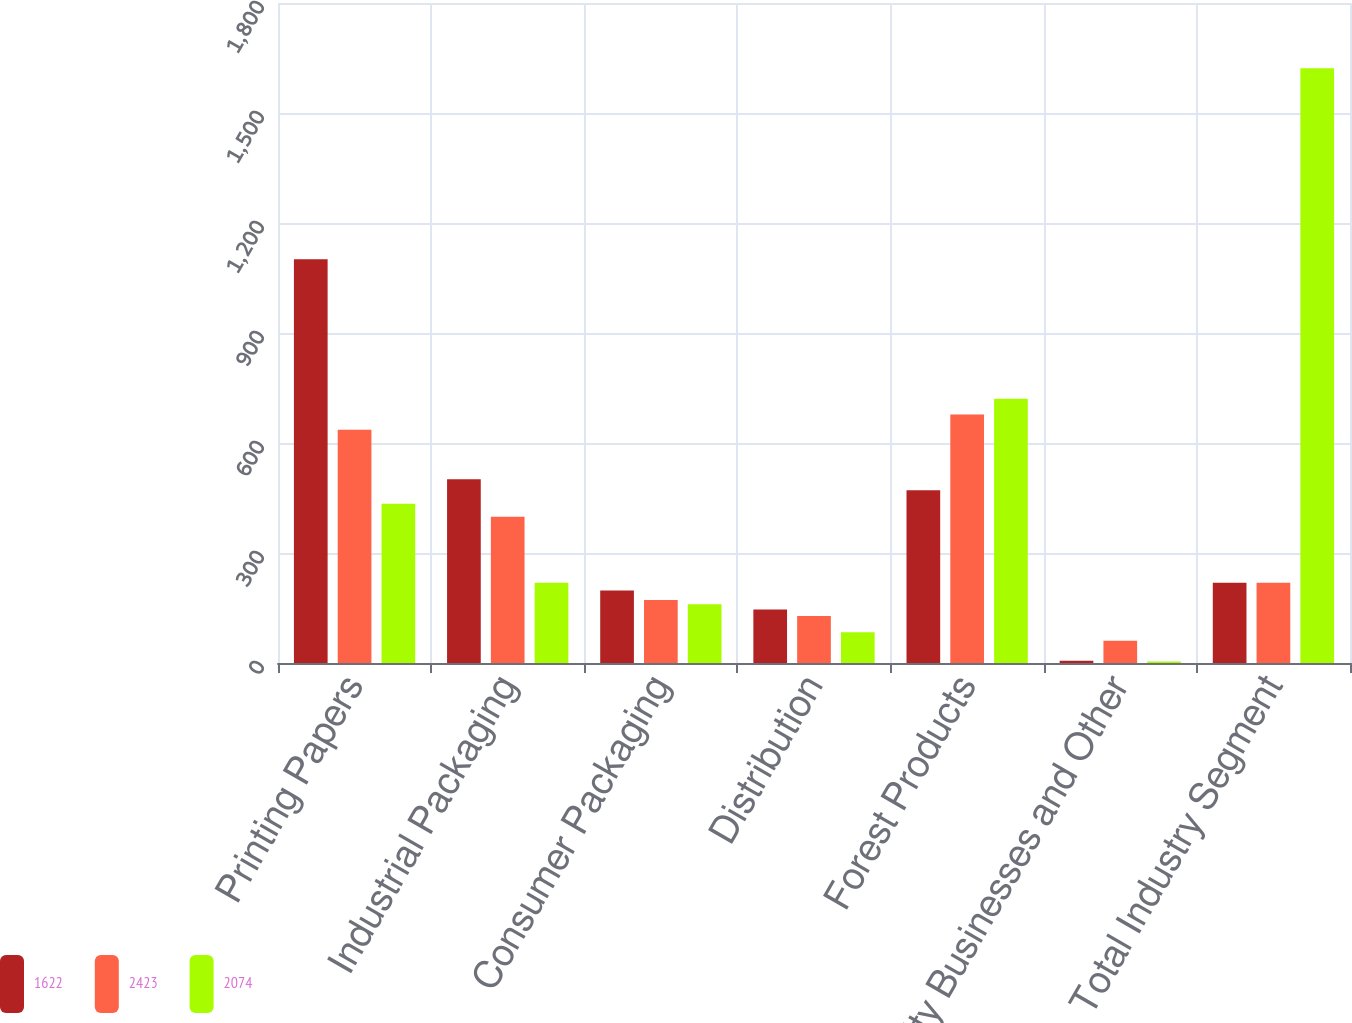<chart> <loc_0><loc_0><loc_500><loc_500><stacked_bar_chart><ecel><fcel>Printing Papers<fcel>Industrial Packaging<fcel>Consumer Packaging<fcel>Distribution<fcel>Forest Products<fcel>Specialty Businesses and Other<fcel>Total Industry Segment<nl><fcel>1622<fcel>1101<fcel>501<fcel>198<fcel>146<fcel>471<fcel>6<fcel>219<nl><fcel>2423<fcel>636<fcel>399<fcel>172<fcel>128<fcel>678<fcel>61<fcel>219<nl><fcel>2074<fcel>434<fcel>219<fcel>160<fcel>84<fcel>721<fcel>4<fcel>1622<nl></chart> 